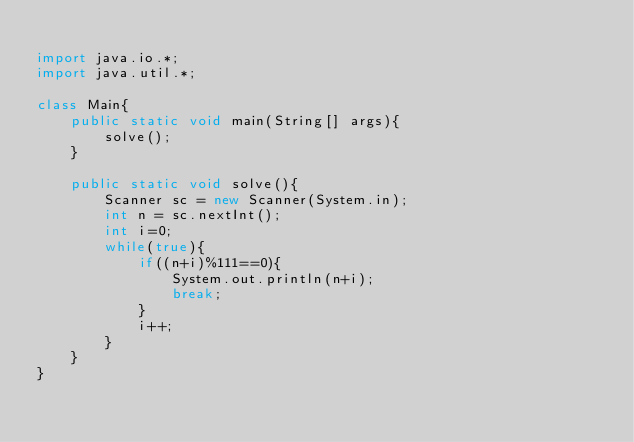<code> <loc_0><loc_0><loc_500><loc_500><_Java_>
import java.io.*;
import java.util.*;

class Main{
    public static void main(String[] args){
        solve();
    }

    public static void solve(){
        Scanner sc = new Scanner(System.in);
        int n = sc.nextInt();
        int i=0;
        while(true){
        	if((n+i)%111==0){
        		System.out.println(n+i);
        		break;
        	}
        	i++;
        }
    }
}</code> 